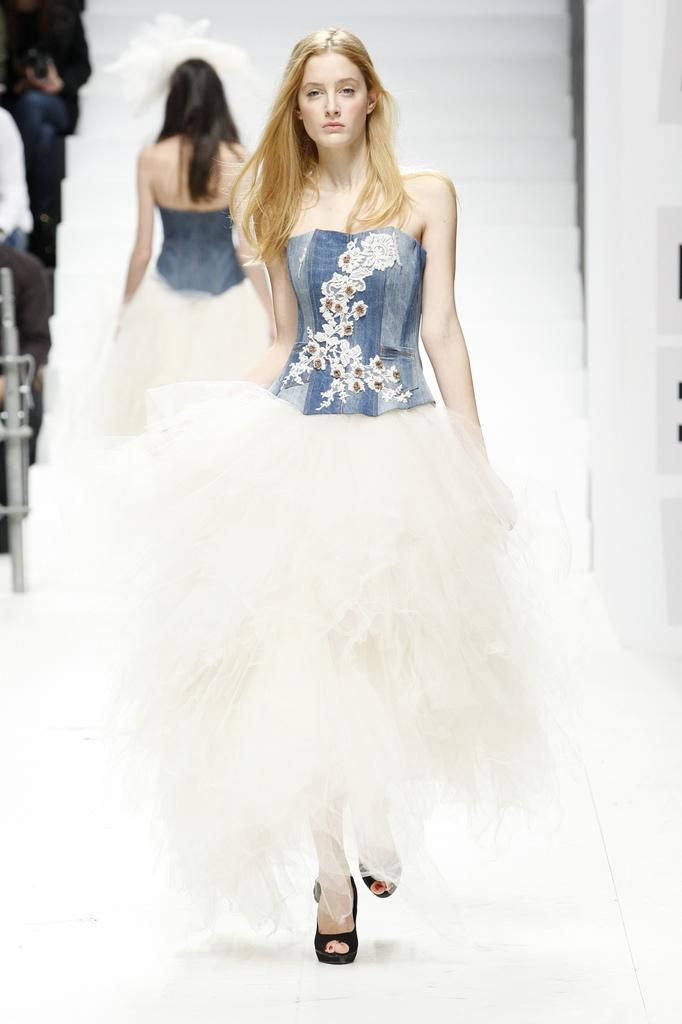How many women are present in the image? There are two women in the image. What are the women doing in the image? The women are walking on a ramp. What are the women wearing in the image? The women are wearing designer clothes. Where is the image taken? The image is taken over a place. What arithmetic problem can be solved using the numbers on the women's clothing? There is no arithmetic problem present on the women's clothing in the image. What type of steel is used to construct the ramp in the image? The image does not provide information about the material used to construct the ramp. 